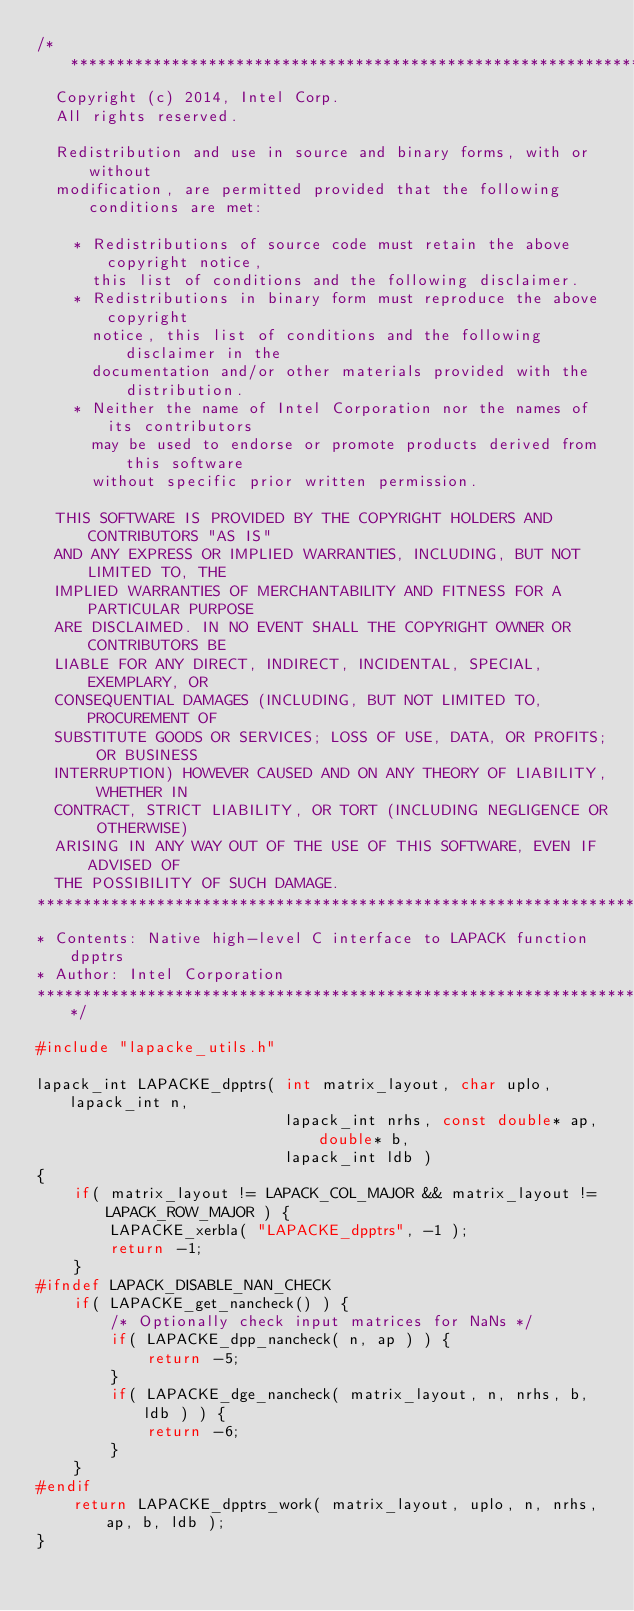Convert code to text. <code><loc_0><loc_0><loc_500><loc_500><_C_>/*****************************************************************************
  Copyright (c) 2014, Intel Corp.
  All rights reserved.

  Redistribution and use in source and binary forms, with or without
  modification, are permitted provided that the following conditions are met:

    * Redistributions of source code must retain the above copyright notice,
      this list of conditions and the following disclaimer.
    * Redistributions in binary form must reproduce the above copyright
      notice, this list of conditions and the following disclaimer in the
      documentation and/or other materials provided with the distribution.
    * Neither the name of Intel Corporation nor the names of its contributors
      may be used to endorse or promote products derived from this software
      without specific prior written permission.

  THIS SOFTWARE IS PROVIDED BY THE COPYRIGHT HOLDERS AND CONTRIBUTORS "AS IS"
  AND ANY EXPRESS OR IMPLIED WARRANTIES, INCLUDING, BUT NOT LIMITED TO, THE
  IMPLIED WARRANTIES OF MERCHANTABILITY AND FITNESS FOR A PARTICULAR PURPOSE
  ARE DISCLAIMED. IN NO EVENT SHALL THE COPYRIGHT OWNER OR CONTRIBUTORS BE
  LIABLE FOR ANY DIRECT, INDIRECT, INCIDENTAL, SPECIAL, EXEMPLARY, OR
  CONSEQUENTIAL DAMAGES (INCLUDING, BUT NOT LIMITED TO, PROCUREMENT OF
  SUBSTITUTE GOODS OR SERVICES; LOSS OF USE, DATA, OR PROFITS; OR BUSINESS
  INTERRUPTION) HOWEVER CAUSED AND ON ANY THEORY OF LIABILITY, WHETHER IN
  CONTRACT, STRICT LIABILITY, OR TORT (INCLUDING NEGLIGENCE OR OTHERWISE)
  ARISING IN ANY WAY OUT OF THE USE OF THIS SOFTWARE, EVEN IF ADVISED OF
  THE POSSIBILITY OF SUCH DAMAGE.
*****************************************************************************
* Contents: Native high-level C interface to LAPACK function dpptrs
* Author: Intel Corporation
*****************************************************************************/

#include "lapacke_utils.h"

lapack_int LAPACKE_dpptrs( int matrix_layout, char uplo, lapack_int n,
                           lapack_int nrhs, const double* ap, double* b,
                           lapack_int ldb )
{
    if( matrix_layout != LAPACK_COL_MAJOR && matrix_layout != LAPACK_ROW_MAJOR ) {
        LAPACKE_xerbla( "LAPACKE_dpptrs", -1 );
        return -1;
    }
#ifndef LAPACK_DISABLE_NAN_CHECK
    if( LAPACKE_get_nancheck() ) {
        /* Optionally check input matrices for NaNs */
        if( LAPACKE_dpp_nancheck( n, ap ) ) {
            return -5;
        }
        if( LAPACKE_dge_nancheck( matrix_layout, n, nrhs, b, ldb ) ) {
            return -6;
        }
    }
#endif
    return LAPACKE_dpptrs_work( matrix_layout, uplo, n, nrhs, ap, b, ldb );
}
</code> 